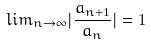<formula> <loc_0><loc_0><loc_500><loc_500>l i m _ { n \rightarrow \infty } | \frac { a _ { n + 1 } } { a _ { n } } | = 1</formula> 